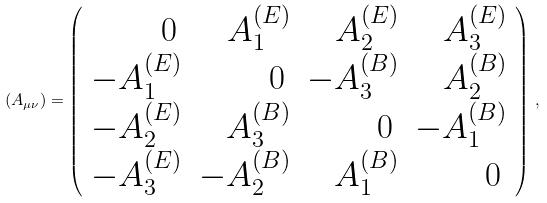<formula> <loc_0><loc_0><loc_500><loc_500>\left ( A _ { \mu \nu } \right ) = \left ( \begin{array} { r r r r } 0 \, & A ^ { ( E ) } _ { 1 } & A ^ { ( E ) } _ { 2 } & A ^ { ( E ) } _ { 3 } \\ - A ^ { ( E ) } _ { 1 } & 0 \, & - A ^ { ( B ) } _ { 3 } & A ^ { ( B ) } _ { 2 } \\ - A ^ { ( E ) } _ { 2 } & A ^ { ( B ) } _ { 3 } & 0 \, & - A ^ { ( B ) } _ { 1 } \\ - A ^ { ( E ) } _ { 3 } & - A ^ { ( B ) } _ { 2 } & A ^ { ( B ) } _ { 1 } & 0 \, \end{array} \right ) \, ,</formula> 